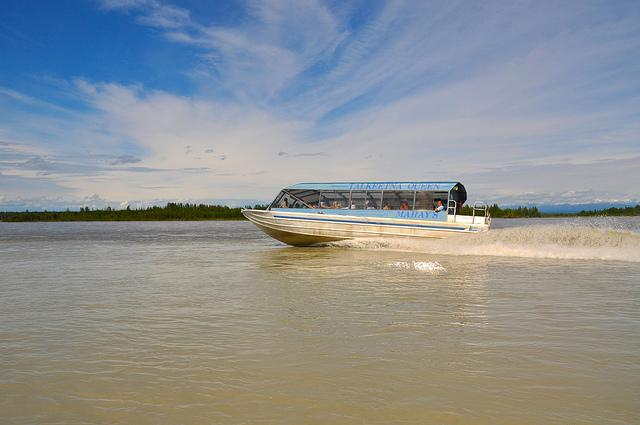What is this watercraft's purpose? transportation 